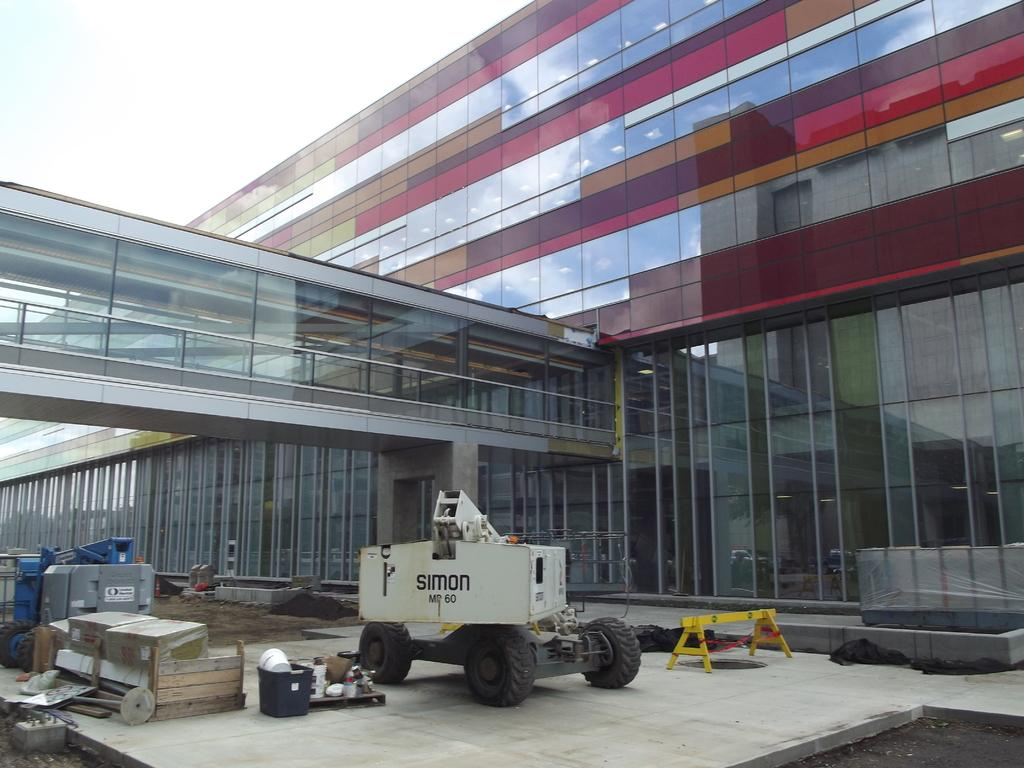What type of building can be seen in the image? There is a building made of glass in the image. What is the cart used for in the image? The purpose of the cart in the image is not specified, but it is likely used for transportation or storage. What are the tires associated with in the image? The tires are likely associated with the cart, as they are commonly used for transportation. What is the solid surface in the image made of? The solid surface in the image could be made of various materials, but it is not specified in the facts provided. What type of natural environment is present in the image? There is sand in the image, which suggests a beach or desert environment. What is visible in the sky in the image? The sky is visible in the image, but the specific weather or time of day is not specified. What type of pancake is being served on the wall in the image? There is no pancake present in the image, nor is there any indication of a wall serving food. 